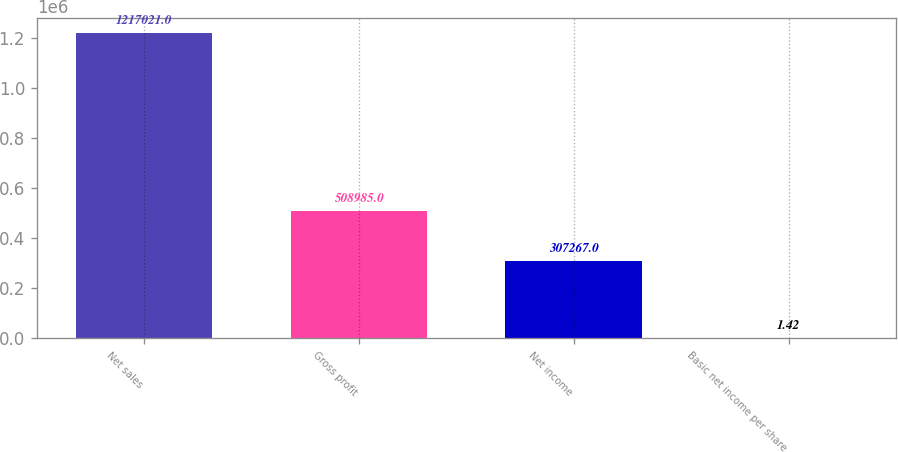<chart> <loc_0><loc_0><loc_500><loc_500><bar_chart><fcel>Net sales<fcel>Gross profit<fcel>Net income<fcel>Basic net income per share<nl><fcel>1.21702e+06<fcel>508985<fcel>307267<fcel>1.42<nl></chart> 